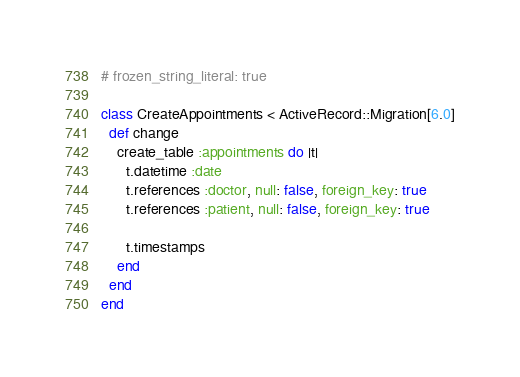Convert code to text. <code><loc_0><loc_0><loc_500><loc_500><_Ruby_># frozen_string_literal: true

class CreateAppointments < ActiveRecord::Migration[6.0]
  def change
    create_table :appointments do |t|
      t.datetime :date
      t.references :doctor, null: false, foreign_key: true
      t.references :patient, null: false, foreign_key: true

      t.timestamps
    end
  end
end
</code> 